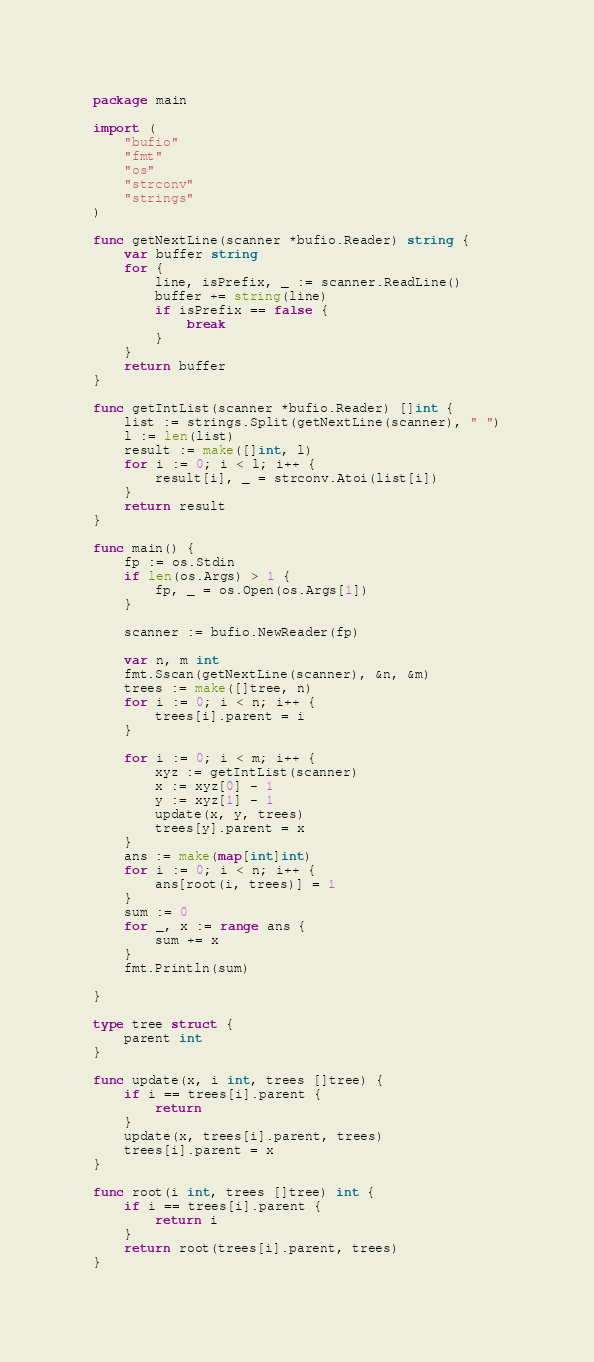<code> <loc_0><loc_0><loc_500><loc_500><_Go_>package main

import (
	"bufio"
	"fmt"
	"os"
	"strconv"
	"strings"
)

func getNextLine(scanner *bufio.Reader) string {
	var buffer string
	for {
		line, isPrefix, _ := scanner.ReadLine()
		buffer += string(line)
		if isPrefix == false {
			break
		}
	}
	return buffer
}

func getIntList(scanner *bufio.Reader) []int {
	list := strings.Split(getNextLine(scanner), " ")
	l := len(list)
	result := make([]int, l)
	for i := 0; i < l; i++ {
		result[i], _ = strconv.Atoi(list[i])
	}
	return result
}

func main() {
	fp := os.Stdin
	if len(os.Args) > 1 {
		fp, _ = os.Open(os.Args[1])
	}

	scanner := bufio.NewReader(fp)

	var n, m int
	fmt.Sscan(getNextLine(scanner), &n, &m)
	trees := make([]tree, n)
	for i := 0; i < n; i++ {
		trees[i].parent = i
	}

	for i := 0; i < m; i++ {
		xyz := getIntList(scanner)
		x := xyz[0] - 1
		y := xyz[1] - 1
		update(x, y, trees)
		trees[y].parent = x
	}
	ans := make(map[int]int)
	for i := 0; i < n; i++ {
		ans[root(i, trees)] = 1
	}
	sum := 0
	for _, x := range ans {
		sum += x
	}
	fmt.Println(sum)

}

type tree struct {
	parent int
}

func update(x, i int, trees []tree) {
	if i == trees[i].parent {
		return
	}
	update(x, trees[i].parent, trees)
	trees[i].parent = x
}

func root(i int, trees []tree) int {
	if i == trees[i].parent {
		return i
	}
	return root(trees[i].parent, trees)
}
</code> 